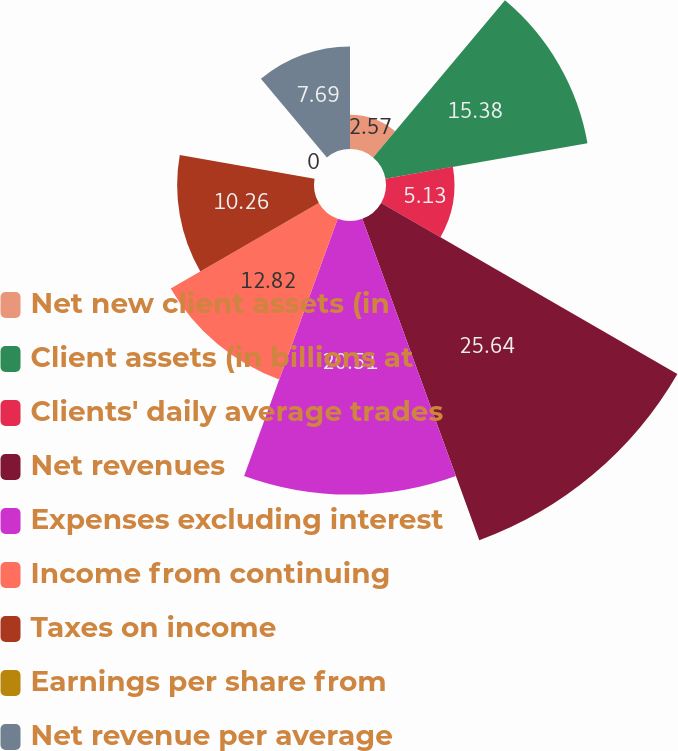Convert chart to OTSL. <chart><loc_0><loc_0><loc_500><loc_500><pie_chart><fcel>Net new client assets (in<fcel>Client assets (in billions at<fcel>Clients' daily average trades<fcel>Net revenues<fcel>Expenses excluding interest<fcel>Income from continuing<fcel>Taxes on income<fcel>Earnings per share from<fcel>Net revenue per average<nl><fcel>2.57%<fcel>15.38%<fcel>5.13%<fcel>25.64%<fcel>20.51%<fcel>12.82%<fcel>10.26%<fcel>0.0%<fcel>7.69%<nl></chart> 